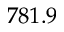Convert formula to latex. <formula><loc_0><loc_0><loc_500><loc_500>7 8 1 . 9</formula> 